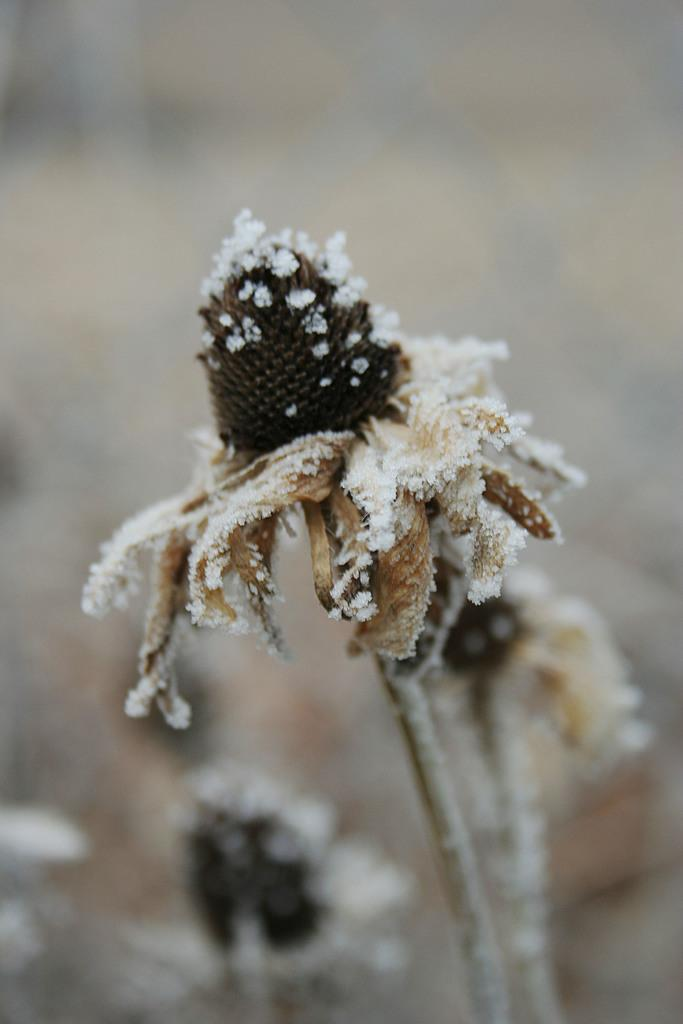What is the main subject of the image? The main subject of the image is a flower. How is the flower affected by the weather or environment in the image? The flower is covered in snow. What type of crook is depicted in the image? There is no crook present in the image; it features a flower covered in snow. What religious symbol can be seen in the image? There is no religious symbol present in the image; it features a flower covered in snow. 